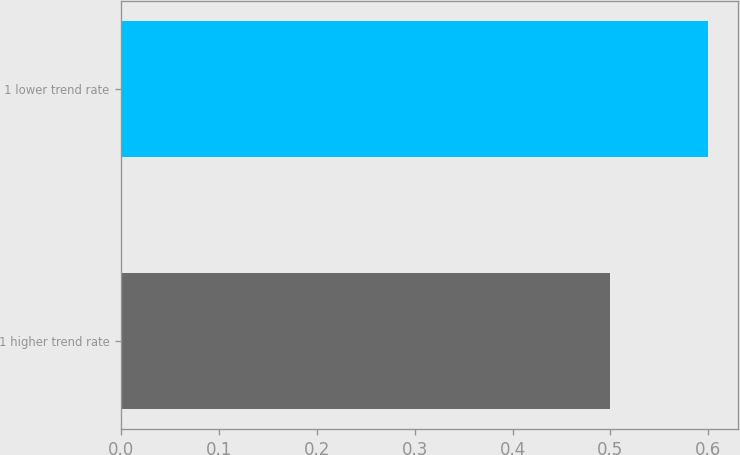<chart> <loc_0><loc_0><loc_500><loc_500><bar_chart><fcel>1 higher trend rate<fcel>1 lower trend rate<nl><fcel>0.5<fcel>0.6<nl></chart> 